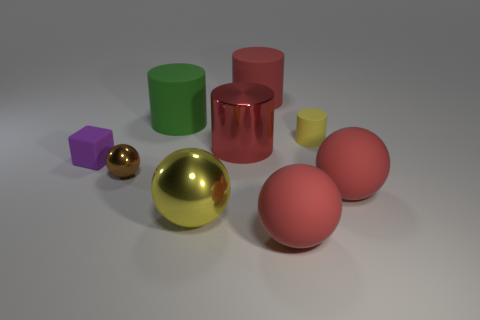Add 1 tiny yellow metal cylinders. How many objects exist? 10 Subtract all spheres. How many objects are left? 5 Subtract 0 purple balls. How many objects are left? 9 Subtract all red spheres. Subtract all green matte things. How many objects are left? 6 Add 8 brown shiny balls. How many brown shiny balls are left? 9 Add 6 small brown shiny things. How many small brown shiny things exist? 7 